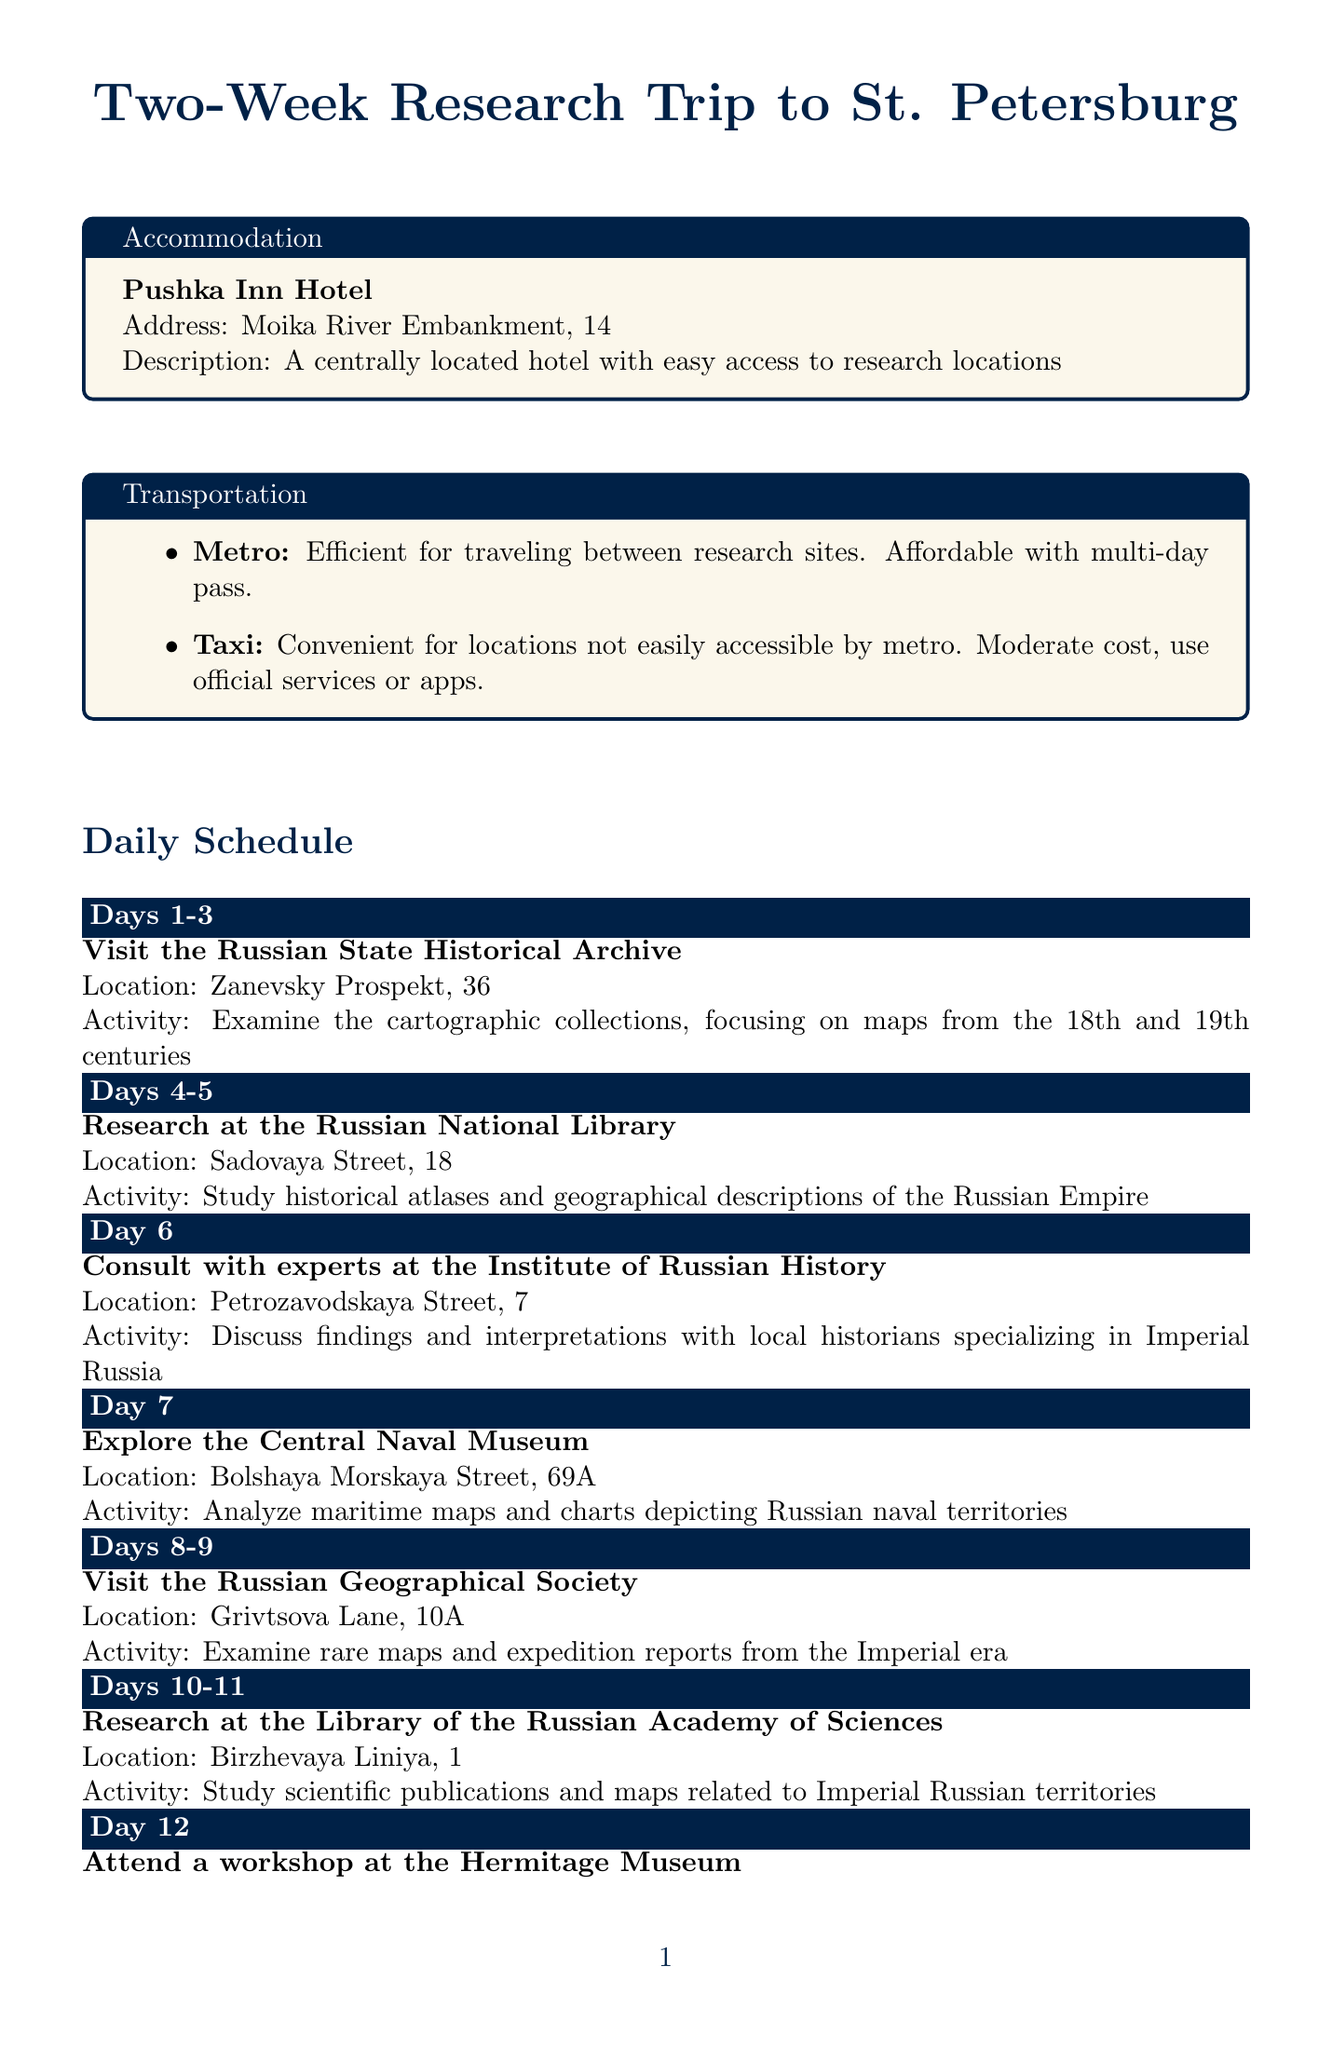What are the research activities planned for Days 1-3? The schedule lists "Visit the Russian State Historical Archive" as the activity for the first three days.
Answer: Visit the Russian State Historical Archive What is the location of the Russian National Library? The document states that the Russian National Library is located on Sadovaya Street, 18.
Answer: Sadovaya Street, 18 How many days is the consultation with experts at the Institute of Russian History? The document specifies that this consultation lasts for 1 day.
Answer: 1 day What transportation mode is described as ideal for research site travel? The document indicates that the Metro is efficient for traveling between research sites.
Answer: Metro What type of maps will be analyzed at the Central Naval Museum? The document states that the focus will be on maritime maps and charts.
Answer: Maritime maps and charts What cultural activity is scheduled for the last day of the trip? The schedule states that on the last day, there will be a "Participate in a roundtable discussion at St. Petersburg State University."
Answer: Participate in a roundtable discussion What is the name of the hotel listed for accommodation? The document specifies the hotel as "Pushka Inn Hotel."
Answer: Pushka Inn Hotel On which day is the workshop at the Hermitage Museum scheduled? According to the schedule, the workshop is planned for Day 12.
Answer: Day 12 